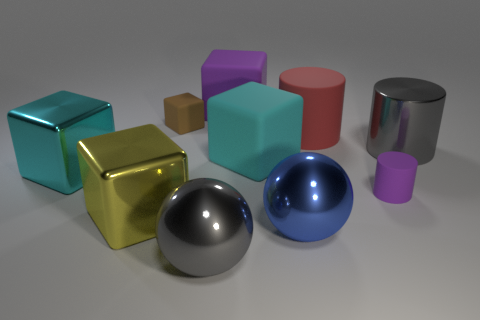What color is the metal cylinder?
Offer a very short reply. Gray. What number of other objects are there of the same material as the big gray ball?
Ensure brevity in your answer.  4. What number of purple objects are either large metallic blocks or big cubes?
Make the answer very short. 1. Does the big cyan thing to the right of the tiny brown cube have the same shape as the rubber object that is in front of the big cyan shiny thing?
Your answer should be compact. No. There is a big matte cylinder; is its color the same as the ball that is on the right side of the large cyan matte object?
Offer a terse response. No. Do the big cylinder on the right side of the big red matte object and the large matte cylinder have the same color?
Make the answer very short. No. How many objects are rubber things or gray objects that are on the left side of the shiny cylinder?
Keep it short and to the point. 6. There is a cylinder that is both in front of the big rubber cylinder and on the left side of the gray metal cylinder; what material is it?
Keep it short and to the point. Rubber. There is a gray object that is on the right side of the large blue ball; what material is it?
Ensure brevity in your answer.  Metal. There is a big cylinder that is the same material as the yellow object; what color is it?
Make the answer very short. Gray. 